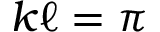<formula> <loc_0><loc_0><loc_500><loc_500>k \ell = \pi</formula> 